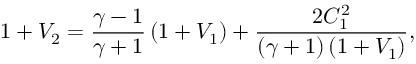Convert formula to latex. <formula><loc_0><loc_0><loc_500><loc_500>1 + V _ { 2 } = \frac { \gamma - 1 } { \gamma + 1 } \left ( 1 + V _ { 1 } \right ) + \frac { 2 C _ { 1 } ^ { 2 } } { \left ( \gamma + 1 \right ) \left ( 1 + V _ { 1 } \right ) } ,</formula> 